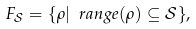<formula> <loc_0><loc_0><loc_500><loc_500>F _ { \mathcal { S } } = \{ \rho | \ r a n g e ( \rho ) \subseteq \mathcal { S } \} ,</formula> 